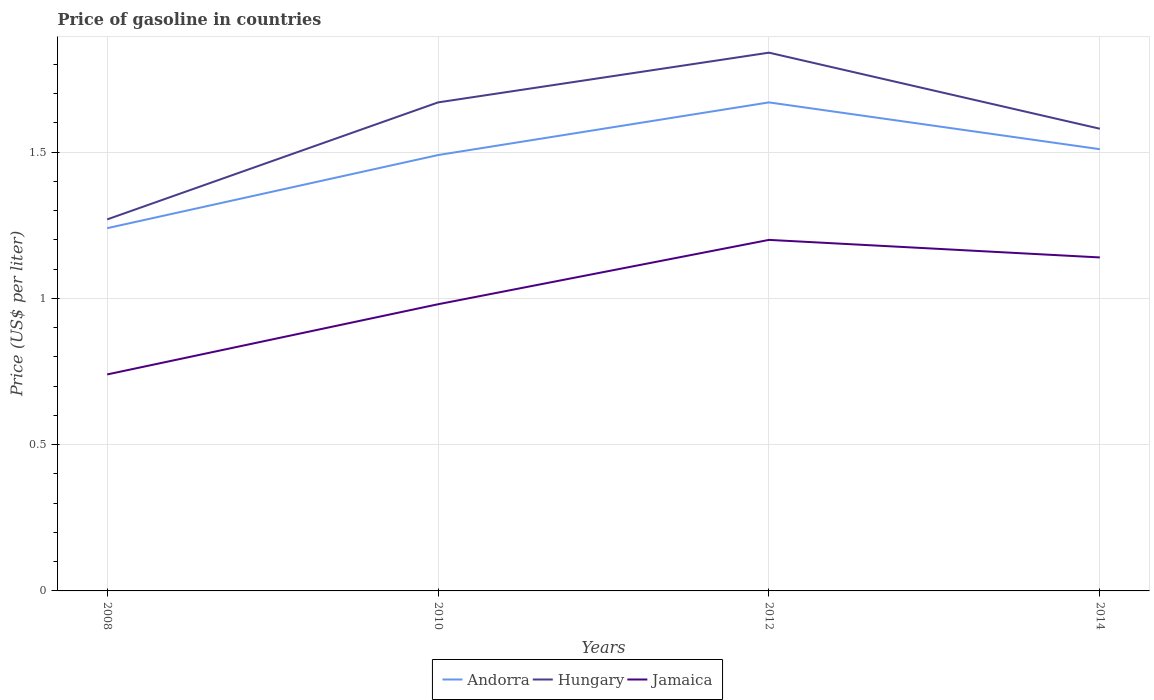Does the line corresponding to Jamaica intersect with the line corresponding to Hungary?
Make the answer very short. No. Is the number of lines equal to the number of legend labels?
Your answer should be very brief. Yes. Across all years, what is the maximum price of gasoline in Jamaica?
Offer a terse response. 0.74. What is the total price of gasoline in Andorra in the graph?
Provide a succinct answer. -0.18. What is the difference between the highest and the second highest price of gasoline in Andorra?
Provide a short and direct response. 0.43. What is the difference between the highest and the lowest price of gasoline in Jamaica?
Your answer should be very brief. 2. What is the difference between two consecutive major ticks on the Y-axis?
Make the answer very short. 0.5. Are the values on the major ticks of Y-axis written in scientific E-notation?
Ensure brevity in your answer.  No. Does the graph contain grids?
Provide a succinct answer. Yes. Where does the legend appear in the graph?
Ensure brevity in your answer.  Bottom center. How are the legend labels stacked?
Provide a short and direct response. Horizontal. What is the title of the graph?
Make the answer very short. Price of gasoline in countries. What is the label or title of the Y-axis?
Your response must be concise. Price (US$ per liter). What is the Price (US$ per liter) in Andorra in 2008?
Ensure brevity in your answer.  1.24. What is the Price (US$ per liter) in Hungary in 2008?
Keep it short and to the point. 1.27. What is the Price (US$ per liter) of Jamaica in 2008?
Keep it short and to the point. 0.74. What is the Price (US$ per liter) of Andorra in 2010?
Keep it short and to the point. 1.49. What is the Price (US$ per liter) of Hungary in 2010?
Offer a very short reply. 1.67. What is the Price (US$ per liter) of Jamaica in 2010?
Offer a very short reply. 0.98. What is the Price (US$ per liter) in Andorra in 2012?
Offer a very short reply. 1.67. What is the Price (US$ per liter) in Hungary in 2012?
Offer a very short reply. 1.84. What is the Price (US$ per liter) of Andorra in 2014?
Provide a succinct answer. 1.51. What is the Price (US$ per liter) in Hungary in 2014?
Your answer should be compact. 1.58. What is the Price (US$ per liter) of Jamaica in 2014?
Offer a very short reply. 1.14. Across all years, what is the maximum Price (US$ per liter) of Andorra?
Offer a terse response. 1.67. Across all years, what is the maximum Price (US$ per liter) in Hungary?
Offer a very short reply. 1.84. Across all years, what is the minimum Price (US$ per liter) of Andorra?
Provide a short and direct response. 1.24. Across all years, what is the minimum Price (US$ per liter) of Hungary?
Give a very brief answer. 1.27. Across all years, what is the minimum Price (US$ per liter) in Jamaica?
Offer a terse response. 0.74. What is the total Price (US$ per liter) in Andorra in the graph?
Give a very brief answer. 5.91. What is the total Price (US$ per liter) of Hungary in the graph?
Offer a very short reply. 6.36. What is the total Price (US$ per liter) of Jamaica in the graph?
Give a very brief answer. 4.06. What is the difference between the Price (US$ per liter) in Jamaica in 2008 and that in 2010?
Provide a succinct answer. -0.24. What is the difference between the Price (US$ per liter) of Andorra in 2008 and that in 2012?
Offer a terse response. -0.43. What is the difference between the Price (US$ per liter) of Hungary in 2008 and that in 2012?
Make the answer very short. -0.57. What is the difference between the Price (US$ per liter) in Jamaica in 2008 and that in 2012?
Offer a terse response. -0.46. What is the difference between the Price (US$ per liter) in Andorra in 2008 and that in 2014?
Your response must be concise. -0.27. What is the difference between the Price (US$ per liter) in Hungary in 2008 and that in 2014?
Your answer should be very brief. -0.31. What is the difference between the Price (US$ per liter) of Andorra in 2010 and that in 2012?
Your answer should be very brief. -0.18. What is the difference between the Price (US$ per liter) of Hungary in 2010 and that in 2012?
Give a very brief answer. -0.17. What is the difference between the Price (US$ per liter) in Jamaica in 2010 and that in 2012?
Your response must be concise. -0.22. What is the difference between the Price (US$ per liter) in Andorra in 2010 and that in 2014?
Provide a succinct answer. -0.02. What is the difference between the Price (US$ per liter) in Hungary in 2010 and that in 2014?
Ensure brevity in your answer.  0.09. What is the difference between the Price (US$ per liter) of Jamaica in 2010 and that in 2014?
Your response must be concise. -0.16. What is the difference between the Price (US$ per liter) of Andorra in 2012 and that in 2014?
Provide a short and direct response. 0.16. What is the difference between the Price (US$ per liter) of Hungary in 2012 and that in 2014?
Provide a short and direct response. 0.26. What is the difference between the Price (US$ per liter) in Andorra in 2008 and the Price (US$ per liter) in Hungary in 2010?
Make the answer very short. -0.43. What is the difference between the Price (US$ per liter) of Andorra in 2008 and the Price (US$ per liter) of Jamaica in 2010?
Make the answer very short. 0.26. What is the difference between the Price (US$ per liter) in Hungary in 2008 and the Price (US$ per liter) in Jamaica in 2010?
Offer a terse response. 0.29. What is the difference between the Price (US$ per liter) of Andorra in 2008 and the Price (US$ per liter) of Hungary in 2012?
Give a very brief answer. -0.6. What is the difference between the Price (US$ per liter) of Hungary in 2008 and the Price (US$ per liter) of Jamaica in 2012?
Offer a very short reply. 0.07. What is the difference between the Price (US$ per liter) of Andorra in 2008 and the Price (US$ per liter) of Hungary in 2014?
Ensure brevity in your answer.  -0.34. What is the difference between the Price (US$ per liter) in Andorra in 2008 and the Price (US$ per liter) in Jamaica in 2014?
Your answer should be very brief. 0.1. What is the difference between the Price (US$ per liter) in Hungary in 2008 and the Price (US$ per liter) in Jamaica in 2014?
Your answer should be very brief. 0.13. What is the difference between the Price (US$ per liter) of Andorra in 2010 and the Price (US$ per liter) of Hungary in 2012?
Offer a very short reply. -0.35. What is the difference between the Price (US$ per liter) of Andorra in 2010 and the Price (US$ per liter) of Jamaica in 2012?
Offer a terse response. 0.29. What is the difference between the Price (US$ per liter) of Hungary in 2010 and the Price (US$ per liter) of Jamaica in 2012?
Provide a succinct answer. 0.47. What is the difference between the Price (US$ per liter) of Andorra in 2010 and the Price (US$ per liter) of Hungary in 2014?
Offer a terse response. -0.09. What is the difference between the Price (US$ per liter) in Hungary in 2010 and the Price (US$ per liter) in Jamaica in 2014?
Your response must be concise. 0.53. What is the difference between the Price (US$ per liter) of Andorra in 2012 and the Price (US$ per liter) of Hungary in 2014?
Your answer should be very brief. 0.09. What is the difference between the Price (US$ per liter) in Andorra in 2012 and the Price (US$ per liter) in Jamaica in 2014?
Make the answer very short. 0.53. What is the average Price (US$ per liter) in Andorra per year?
Provide a succinct answer. 1.48. What is the average Price (US$ per liter) of Hungary per year?
Give a very brief answer. 1.59. What is the average Price (US$ per liter) of Jamaica per year?
Provide a short and direct response. 1.01. In the year 2008, what is the difference between the Price (US$ per liter) of Andorra and Price (US$ per liter) of Hungary?
Keep it short and to the point. -0.03. In the year 2008, what is the difference between the Price (US$ per liter) of Hungary and Price (US$ per liter) of Jamaica?
Offer a terse response. 0.53. In the year 2010, what is the difference between the Price (US$ per liter) in Andorra and Price (US$ per liter) in Hungary?
Offer a terse response. -0.18. In the year 2010, what is the difference between the Price (US$ per liter) in Andorra and Price (US$ per liter) in Jamaica?
Provide a succinct answer. 0.51. In the year 2010, what is the difference between the Price (US$ per liter) of Hungary and Price (US$ per liter) of Jamaica?
Provide a short and direct response. 0.69. In the year 2012, what is the difference between the Price (US$ per liter) of Andorra and Price (US$ per liter) of Hungary?
Ensure brevity in your answer.  -0.17. In the year 2012, what is the difference between the Price (US$ per liter) in Andorra and Price (US$ per liter) in Jamaica?
Make the answer very short. 0.47. In the year 2012, what is the difference between the Price (US$ per liter) in Hungary and Price (US$ per liter) in Jamaica?
Give a very brief answer. 0.64. In the year 2014, what is the difference between the Price (US$ per liter) of Andorra and Price (US$ per liter) of Hungary?
Keep it short and to the point. -0.07. In the year 2014, what is the difference between the Price (US$ per liter) of Andorra and Price (US$ per liter) of Jamaica?
Give a very brief answer. 0.37. In the year 2014, what is the difference between the Price (US$ per liter) in Hungary and Price (US$ per liter) in Jamaica?
Provide a succinct answer. 0.44. What is the ratio of the Price (US$ per liter) in Andorra in 2008 to that in 2010?
Provide a short and direct response. 0.83. What is the ratio of the Price (US$ per liter) of Hungary in 2008 to that in 2010?
Offer a very short reply. 0.76. What is the ratio of the Price (US$ per liter) in Jamaica in 2008 to that in 2010?
Offer a very short reply. 0.76. What is the ratio of the Price (US$ per liter) of Andorra in 2008 to that in 2012?
Give a very brief answer. 0.74. What is the ratio of the Price (US$ per liter) in Hungary in 2008 to that in 2012?
Give a very brief answer. 0.69. What is the ratio of the Price (US$ per liter) in Jamaica in 2008 to that in 2012?
Ensure brevity in your answer.  0.62. What is the ratio of the Price (US$ per liter) in Andorra in 2008 to that in 2014?
Give a very brief answer. 0.82. What is the ratio of the Price (US$ per liter) in Hungary in 2008 to that in 2014?
Provide a short and direct response. 0.8. What is the ratio of the Price (US$ per liter) of Jamaica in 2008 to that in 2014?
Provide a succinct answer. 0.65. What is the ratio of the Price (US$ per liter) in Andorra in 2010 to that in 2012?
Your answer should be very brief. 0.89. What is the ratio of the Price (US$ per liter) in Hungary in 2010 to that in 2012?
Offer a very short reply. 0.91. What is the ratio of the Price (US$ per liter) in Jamaica in 2010 to that in 2012?
Your answer should be very brief. 0.82. What is the ratio of the Price (US$ per liter) in Hungary in 2010 to that in 2014?
Ensure brevity in your answer.  1.06. What is the ratio of the Price (US$ per liter) of Jamaica in 2010 to that in 2014?
Ensure brevity in your answer.  0.86. What is the ratio of the Price (US$ per liter) in Andorra in 2012 to that in 2014?
Ensure brevity in your answer.  1.11. What is the ratio of the Price (US$ per liter) in Hungary in 2012 to that in 2014?
Offer a terse response. 1.16. What is the ratio of the Price (US$ per liter) in Jamaica in 2012 to that in 2014?
Provide a short and direct response. 1.05. What is the difference between the highest and the second highest Price (US$ per liter) of Andorra?
Your answer should be compact. 0.16. What is the difference between the highest and the second highest Price (US$ per liter) of Hungary?
Keep it short and to the point. 0.17. What is the difference between the highest and the lowest Price (US$ per liter) in Andorra?
Provide a short and direct response. 0.43. What is the difference between the highest and the lowest Price (US$ per liter) in Hungary?
Make the answer very short. 0.57. What is the difference between the highest and the lowest Price (US$ per liter) of Jamaica?
Keep it short and to the point. 0.46. 